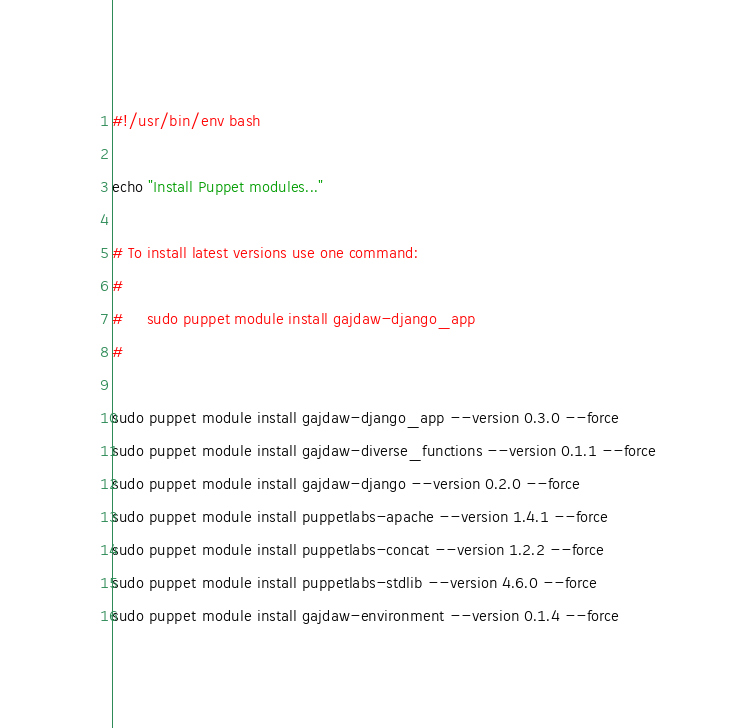Convert code to text. <code><loc_0><loc_0><loc_500><loc_500><_Bash_>#!/usr/bin/env bash

echo "Install Puppet modules..."

# To install latest versions use one command:
#
#     sudo puppet module install gajdaw-django_app
#

sudo puppet module install gajdaw-django_app --version 0.3.0 --force
sudo puppet module install gajdaw-diverse_functions --version 0.1.1 --force
sudo puppet module install gajdaw-django --version 0.2.0 --force
sudo puppet module install puppetlabs-apache --version 1.4.1 --force
sudo puppet module install puppetlabs-concat --version 1.2.2 --force
sudo puppet module install puppetlabs-stdlib --version 4.6.0 --force
sudo puppet module install gajdaw-environment --version 0.1.4 --force</code> 